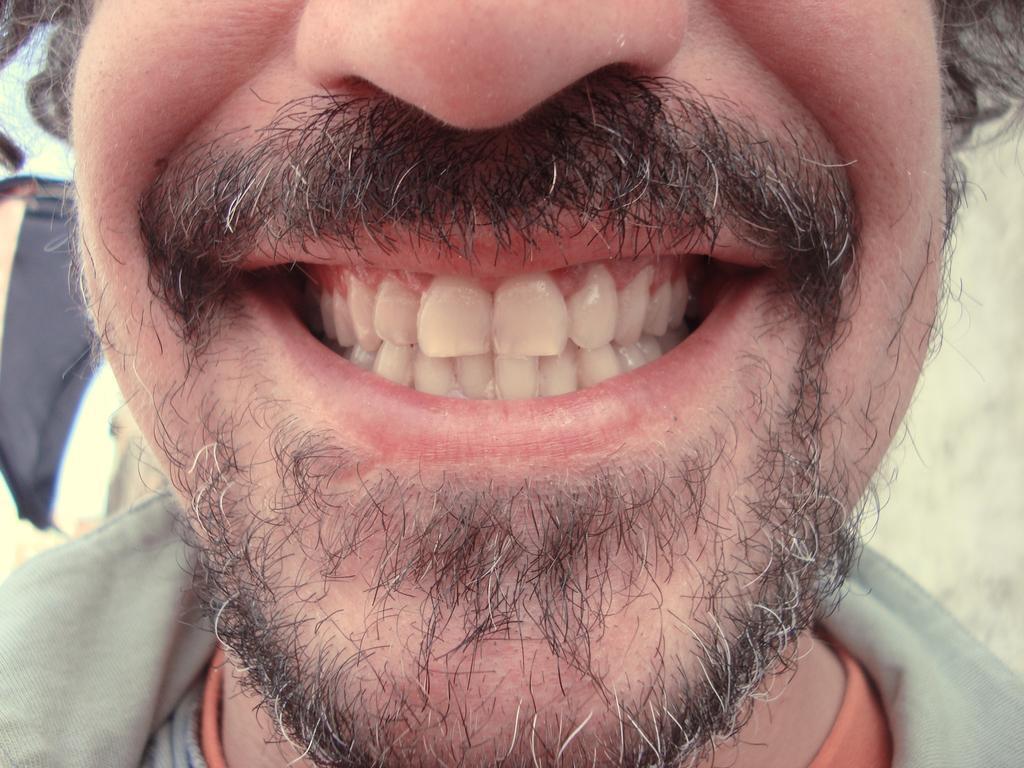In one or two sentences, can you explain what this image depicts? It is a zoomed in picture of a person's teeth. 